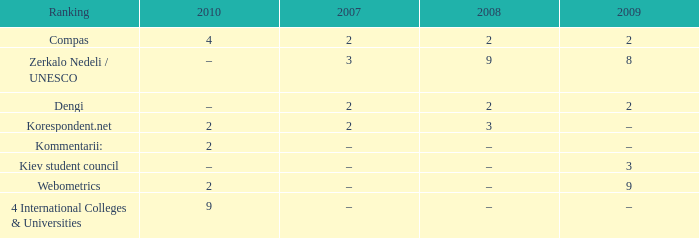What was the 2009 ranking for Webometrics? 9.0. 